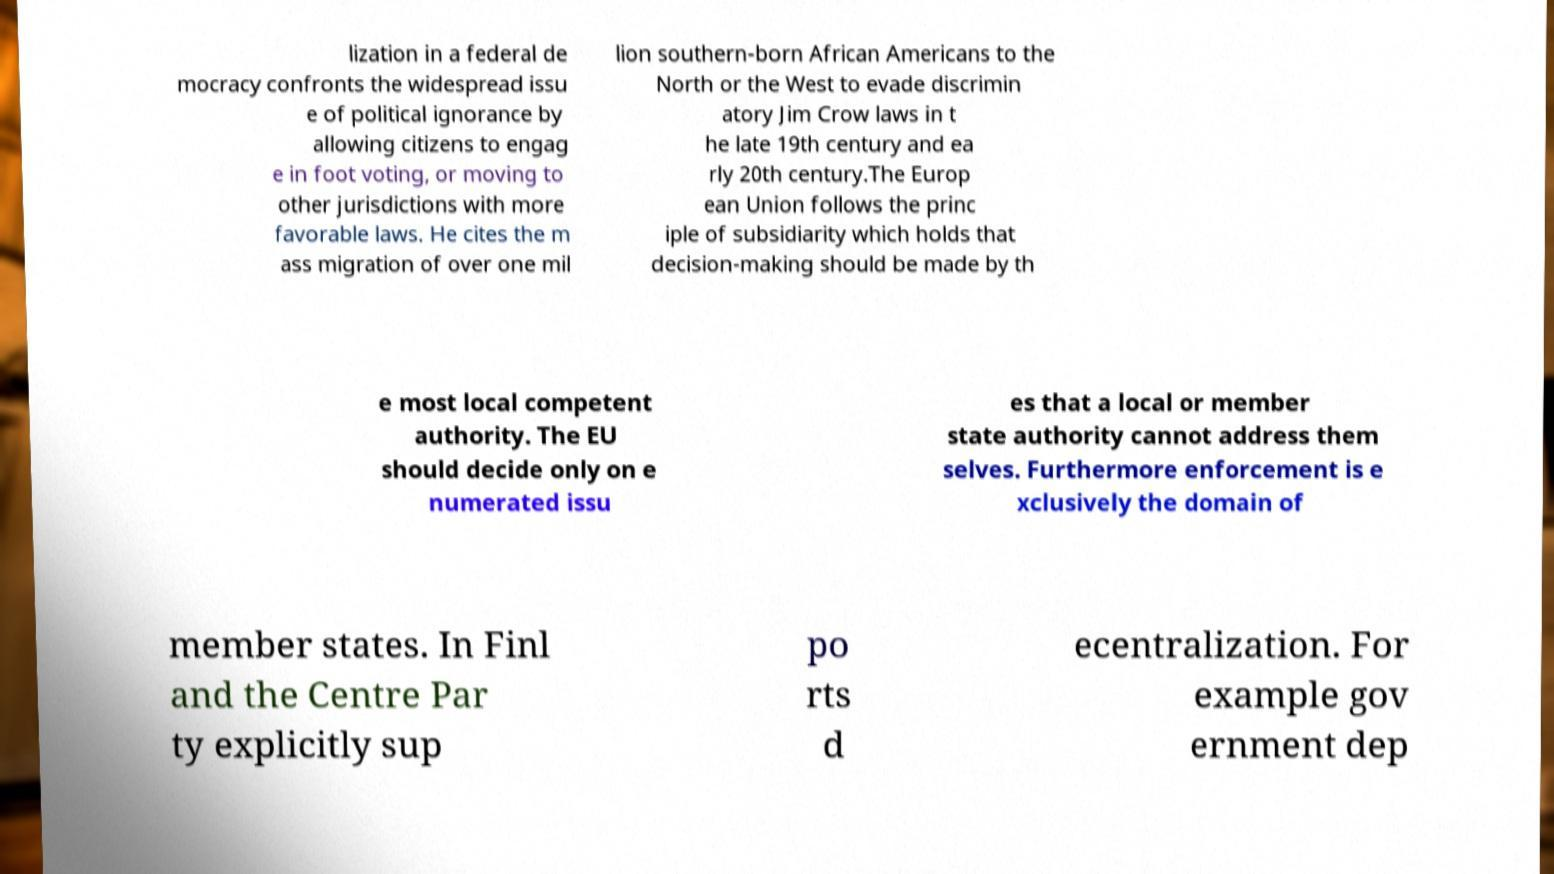Could you extract and type out the text from this image? lization in a federal de mocracy confronts the widespread issu e of political ignorance by allowing citizens to engag e in foot voting, or moving to other jurisdictions with more favorable laws. He cites the m ass migration of over one mil lion southern-born African Americans to the North or the West to evade discrimin atory Jim Crow laws in t he late 19th century and ea rly 20th century.The Europ ean Union follows the princ iple of subsidiarity which holds that decision-making should be made by th e most local competent authority. The EU should decide only on e numerated issu es that a local or member state authority cannot address them selves. Furthermore enforcement is e xclusively the domain of member states. In Finl and the Centre Par ty explicitly sup po rts d ecentralization. For example gov ernment dep 